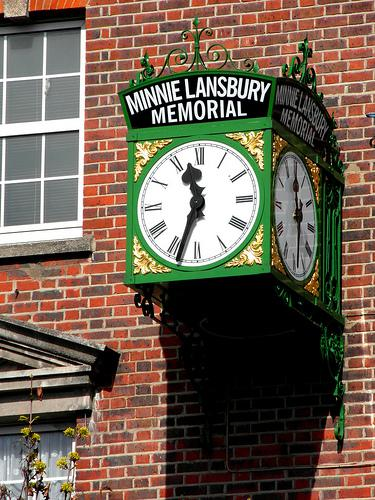Question: how many words are on the sign?
Choices:
A. One.
B. Two.
C. None.
D. Three.
Answer with the letter. Answer: D Question: how many plants are in front of the little window?
Choices:
A. Two.
B. One.
C. Three.
D. Four.
Answer with the letter. Answer: A Question: when was the picture taken?
Choices:
A. 12:00.
B. 11:33.
C. 1:00.
D. 2:00.
Answer with the letter. Answer: B Question: when was this picture taken?
Choices:
A. At night.
B. In the morning.
C. During the day.
D. In the evening.
Answer with the letter. Answer: C 